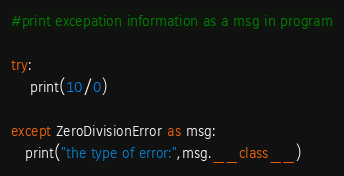Convert code to text. <code><loc_0><loc_0><loc_500><loc_500><_Python_>#print excepation information as a msg in program

try:
    print(10/0)

except ZeroDivisionError as msg:
   print("the type of error:",msg.__class__)
</code> 